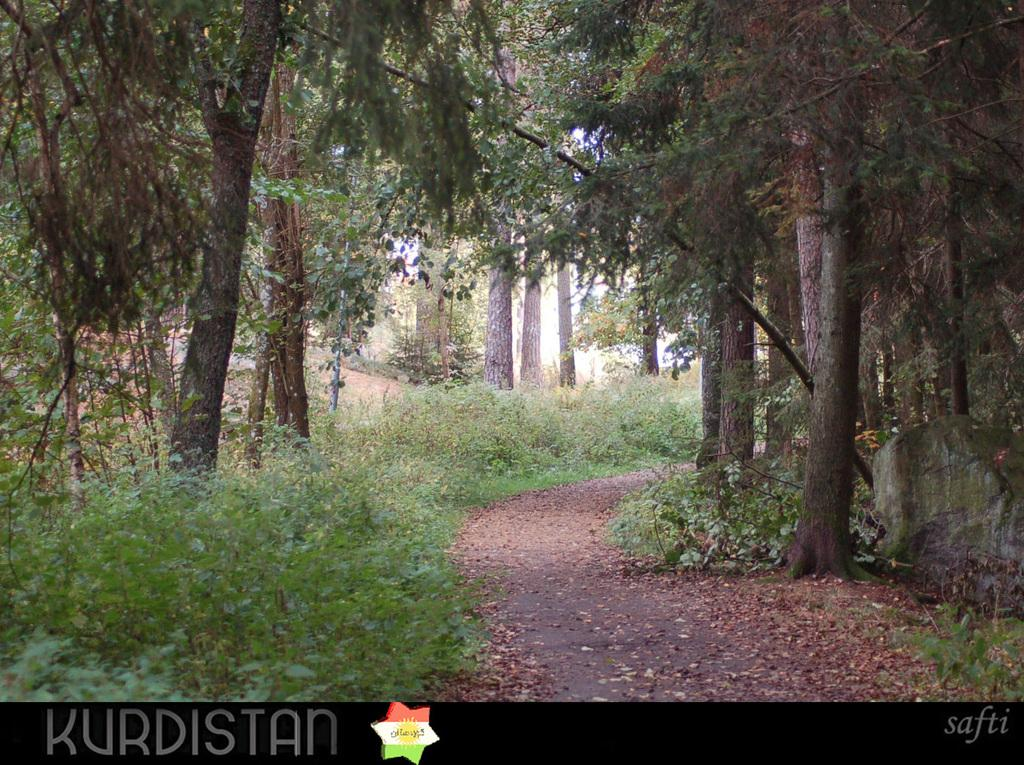What is the main feature of the image? There is a road in the image. What type of natural elements can be seen in the image? There are shredded leaves, plants, and trees visible in the image. What part of the natural environment is visible in the image? The sky is visible in the image. What level of payment is required to access the road in the image? There is no information about payment or access to the road in the image. What type of frame is surrounding the image? There is no frame visible in the image; it only shows the road, natural elements, and the sky. 